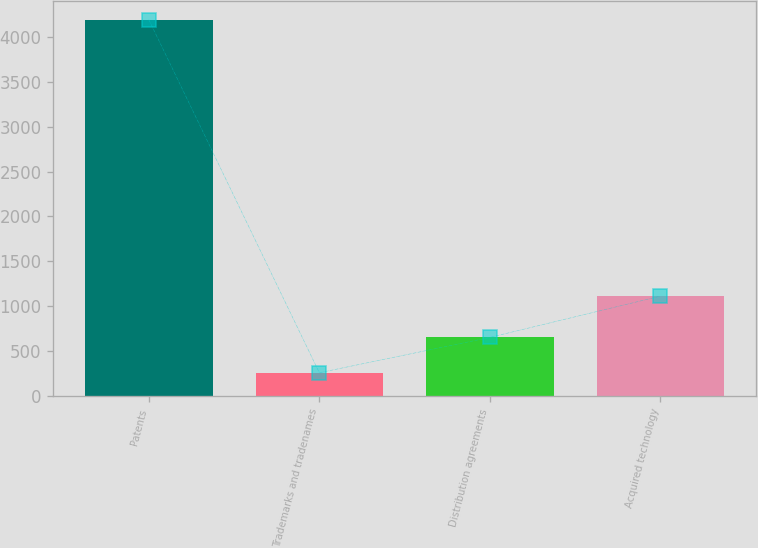Convert chart to OTSL. <chart><loc_0><loc_0><loc_500><loc_500><bar_chart><fcel>Patents<fcel>Trademarks and tradenames<fcel>Distribution agreements<fcel>Acquired technology<nl><fcel>4192<fcel>259<fcel>652.3<fcel>1112<nl></chart> 